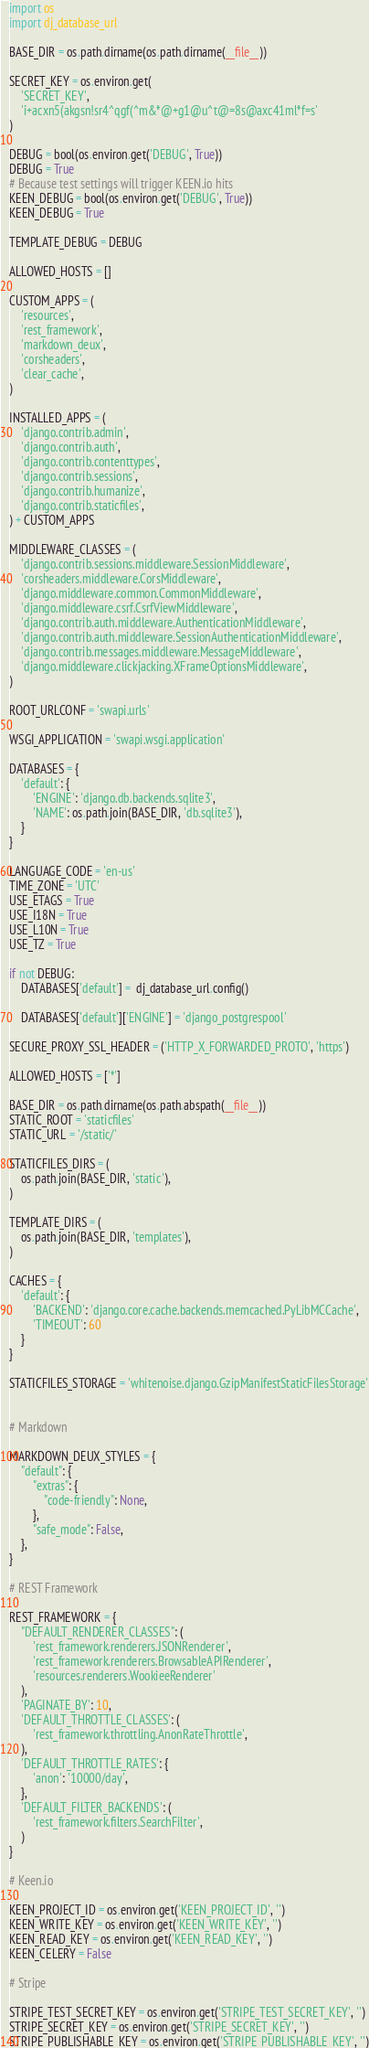<code> <loc_0><loc_0><loc_500><loc_500><_Python_>import os
import dj_database_url

BASE_DIR = os.path.dirname(os.path.dirname(__file__))

SECRET_KEY = os.environ.get(
    'SECRET_KEY',
    'i+acxn5(akgsn!sr4^qgf(^m&*@+g1@u^t@=8s@axc41ml*f=s'
)

DEBUG = bool(os.environ.get('DEBUG', True))
DEBUG = True
# Because test settings will trigger KEEN.io hits
KEEN_DEBUG = bool(os.environ.get('DEBUG', True))
KEEN_DEBUG = True

TEMPLATE_DEBUG = DEBUG

ALLOWED_HOSTS = []

CUSTOM_APPS = (
    'resources',
    'rest_framework',
    'markdown_deux',
    'corsheaders',
    'clear_cache',
)

INSTALLED_APPS = (
    'django.contrib.admin',
    'django.contrib.auth',
    'django.contrib.contenttypes',
    'django.contrib.sessions',
    'django.contrib.humanize',
    'django.contrib.staticfiles',
) + CUSTOM_APPS

MIDDLEWARE_CLASSES = (
    'django.contrib.sessions.middleware.SessionMiddleware',
    'corsheaders.middleware.CorsMiddleware',
    'django.middleware.common.CommonMiddleware',
    'django.middleware.csrf.CsrfViewMiddleware',
    'django.contrib.auth.middleware.AuthenticationMiddleware',
    'django.contrib.auth.middleware.SessionAuthenticationMiddleware',
    'django.contrib.messages.middleware.MessageMiddleware',
    'django.middleware.clickjacking.XFrameOptionsMiddleware',
)

ROOT_URLCONF = 'swapi.urls'

WSGI_APPLICATION = 'swapi.wsgi.application'

DATABASES = {
    'default': {
        'ENGINE': 'django.db.backends.sqlite3',
        'NAME': os.path.join(BASE_DIR, 'db.sqlite3'),
    }
}

LANGUAGE_CODE = 'en-us'
TIME_ZONE = 'UTC'
USE_ETAGS = True
USE_I18N = True
USE_L10N = True
USE_TZ = True

if not DEBUG:
    DATABASES['default'] =  dj_database_url.config()

    DATABASES['default']['ENGINE'] = 'django_postgrespool'

SECURE_PROXY_SSL_HEADER = ('HTTP_X_FORWARDED_PROTO', 'https')

ALLOWED_HOSTS = ['*']

BASE_DIR = os.path.dirname(os.path.abspath(__file__))
STATIC_ROOT = 'staticfiles'
STATIC_URL = '/static/'

STATICFILES_DIRS = (
    os.path.join(BASE_DIR, 'static'),
)

TEMPLATE_DIRS = (
    os.path.join(BASE_DIR, 'templates'),
)

CACHES = {
    'default': {
        'BACKEND': 'django.core.cache.backends.memcached.PyLibMCCache',
        'TIMEOUT': 60
    }
}

STATICFILES_STORAGE = 'whitenoise.django.GzipManifestStaticFilesStorage'


# Markdown

MARKDOWN_DEUX_STYLES = {
    "default": {
        "extras": {
            "code-friendly": None,
        },
        "safe_mode": False,
    },
}

# REST Framework

REST_FRAMEWORK = {
    "DEFAULT_RENDERER_CLASSES": (
        'rest_framework.renderers.JSONRenderer',
        'rest_framework.renderers.BrowsableAPIRenderer',
        'resources.renderers.WookieeRenderer'
    ),
    'PAGINATE_BY': 10,
    'DEFAULT_THROTTLE_CLASSES': (
        'rest_framework.throttling.AnonRateThrottle',
    ),
    'DEFAULT_THROTTLE_RATES': {
        'anon': '10000/day',
    },
    'DEFAULT_FILTER_BACKENDS': (
        'rest_framework.filters.SearchFilter',
    )
}

# Keen.io

KEEN_PROJECT_ID = os.environ.get('KEEN_PROJECT_ID', '')
KEEN_WRITE_KEY = os.environ.get('KEEN_WRITE_KEY', '')
KEEN_READ_KEY = os.environ.get('KEEN_READ_KEY', '')
KEEN_CELERY = False

# Stripe

STRIPE_TEST_SECRET_KEY = os.environ.get('STRIPE_TEST_SECRET_KEY', '')
STRIPE_SECRET_KEY = os.environ.get('STRIPE_SECRET_KEY', '')
STRIPE_PUBLISHABLE_KEY = os.environ.get('STRIPE_PUBLISHABLE_KEY', '')</code> 